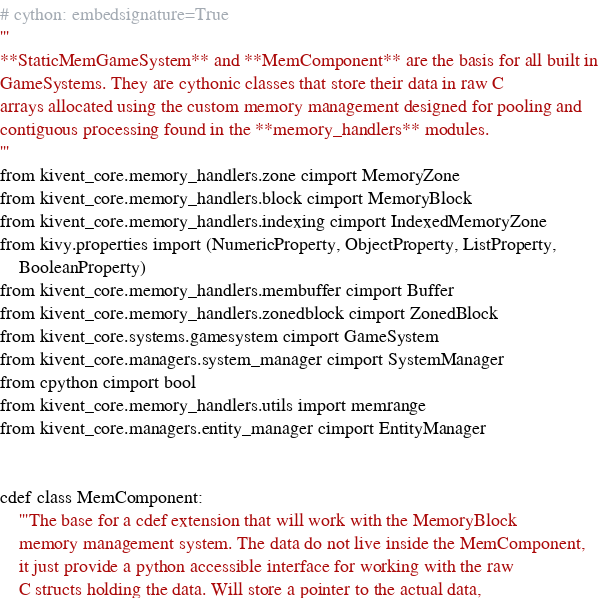<code> <loc_0><loc_0><loc_500><loc_500><_Cython_># cython: embedsignature=True
'''
**StaticMemGameSystem** and **MemComponent** are the basis for all built in
GameSystems. They are cythonic classes that store their data in raw C
arrays allocated using the custom memory management designed for pooling and
contiguous processing found in the **memory_handlers** modules.
'''
from kivent_core.memory_handlers.zone cimport MemoryZone
from kivent_core.memory_handlers.block cimport MemoryBlock
from kivent_core.memory_handlers.indexing cimport IndexedMemoryZone
from kivy.properties import (NumericProperty, ObjectProperty, ListProperty,
    BooleanProperty)
from kivent_core.memory_handlers.membuffer cimport Buffer
from kivent_core.memory_handlers.zonedblock cimport ZonedBlock
from kivent_core.systems.gamesystem cimport GameSystem
from kivent_core.managers.system_manager cimport SystemManager
from cpython cimport bool
from kivent_core.memory_handlers.utils import memrange
from kivent_core.managers.entity_manager cimport EntityManager


cdef class MemComponent:
    '''The base for a cdef extension that will work with the MemoryBlock
    memory management system. The data do not live inside the MemComponent,
    it just provide a python accessible interface for working with the raw
    C structs holding the data. Will store a pointer to the actual data,</code> 